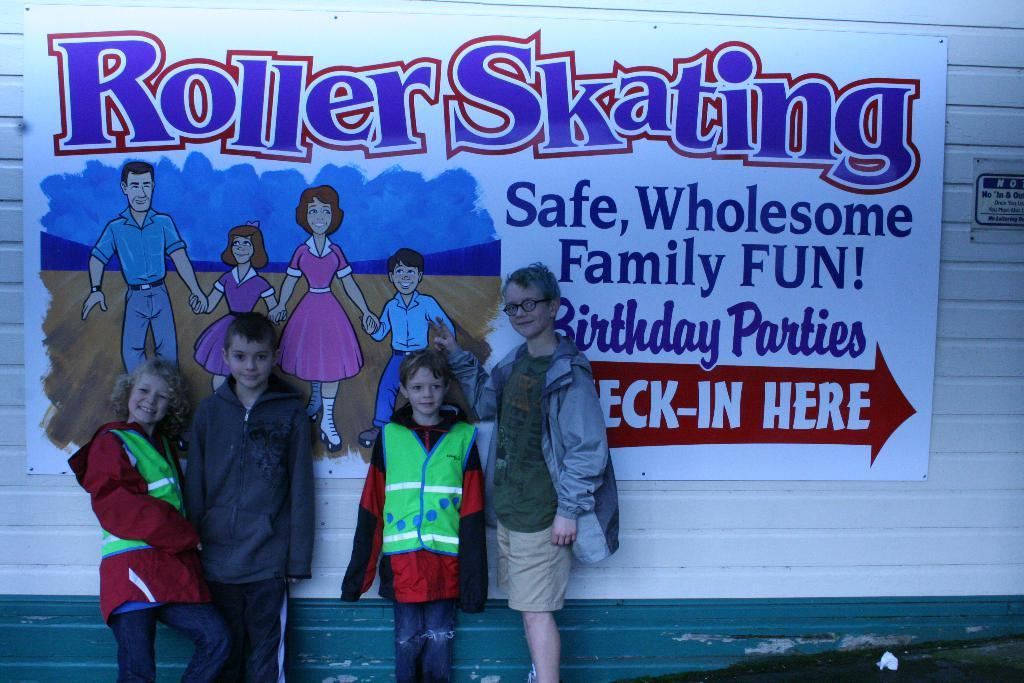<image>
Share a concise interpretation of the image provided. A group of children wearing jackets are standing in front of a sign that says Roller Skating. 